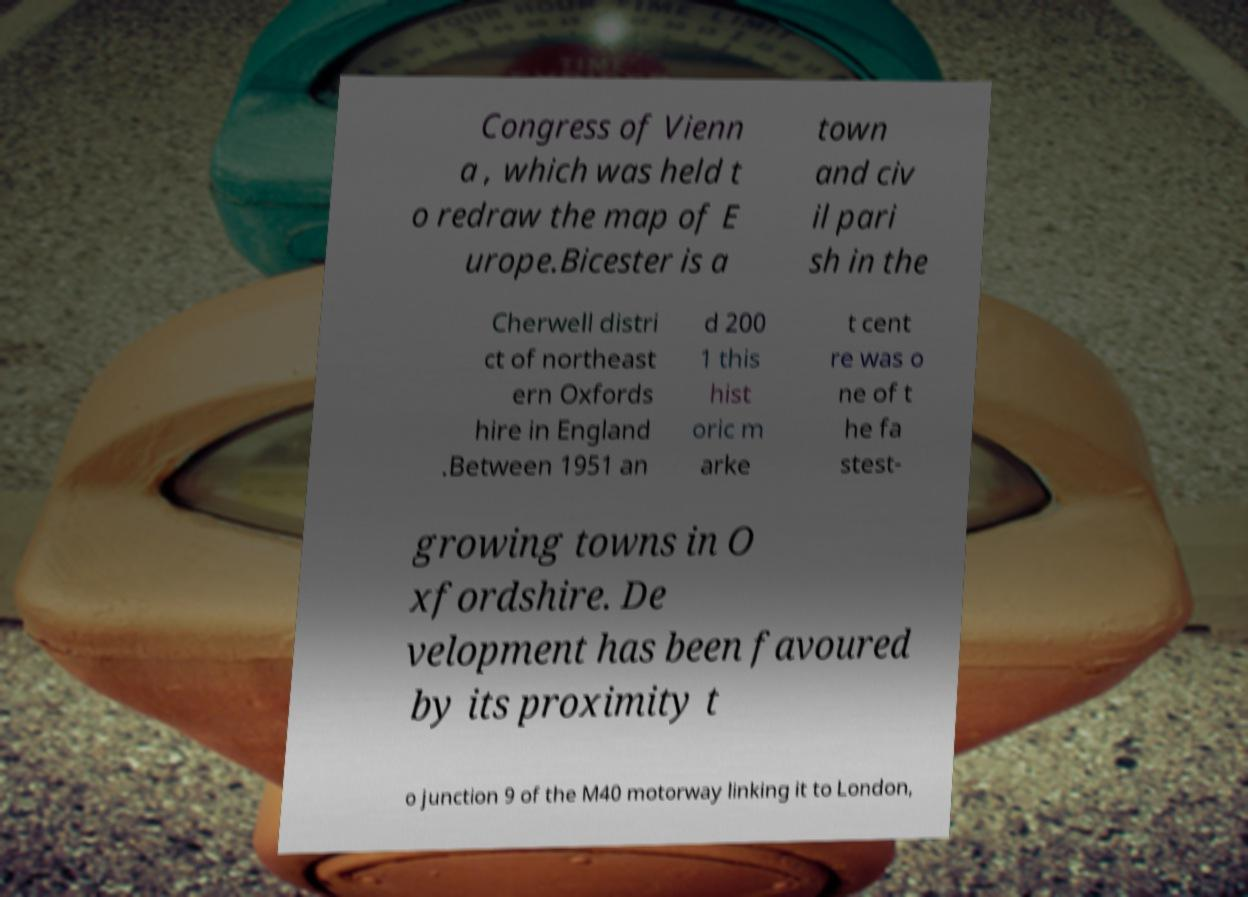What messages or text are displayed in this image? I need them in a readable, typed format. Congress of Vienn a , which was held t o redraw the map of E urope.Bicester is a town and civ il pari sh in the Cherwell distri ct of northeast ern Oxfords hire in England .Between 1951 an d 200 1 this hist oric m arke t cent re was o ne of t he fa stest- growing towns in O xfordshire. De velopment has been favoured by its proximity t o junction 9 of the M40 motorway linking it to London, 